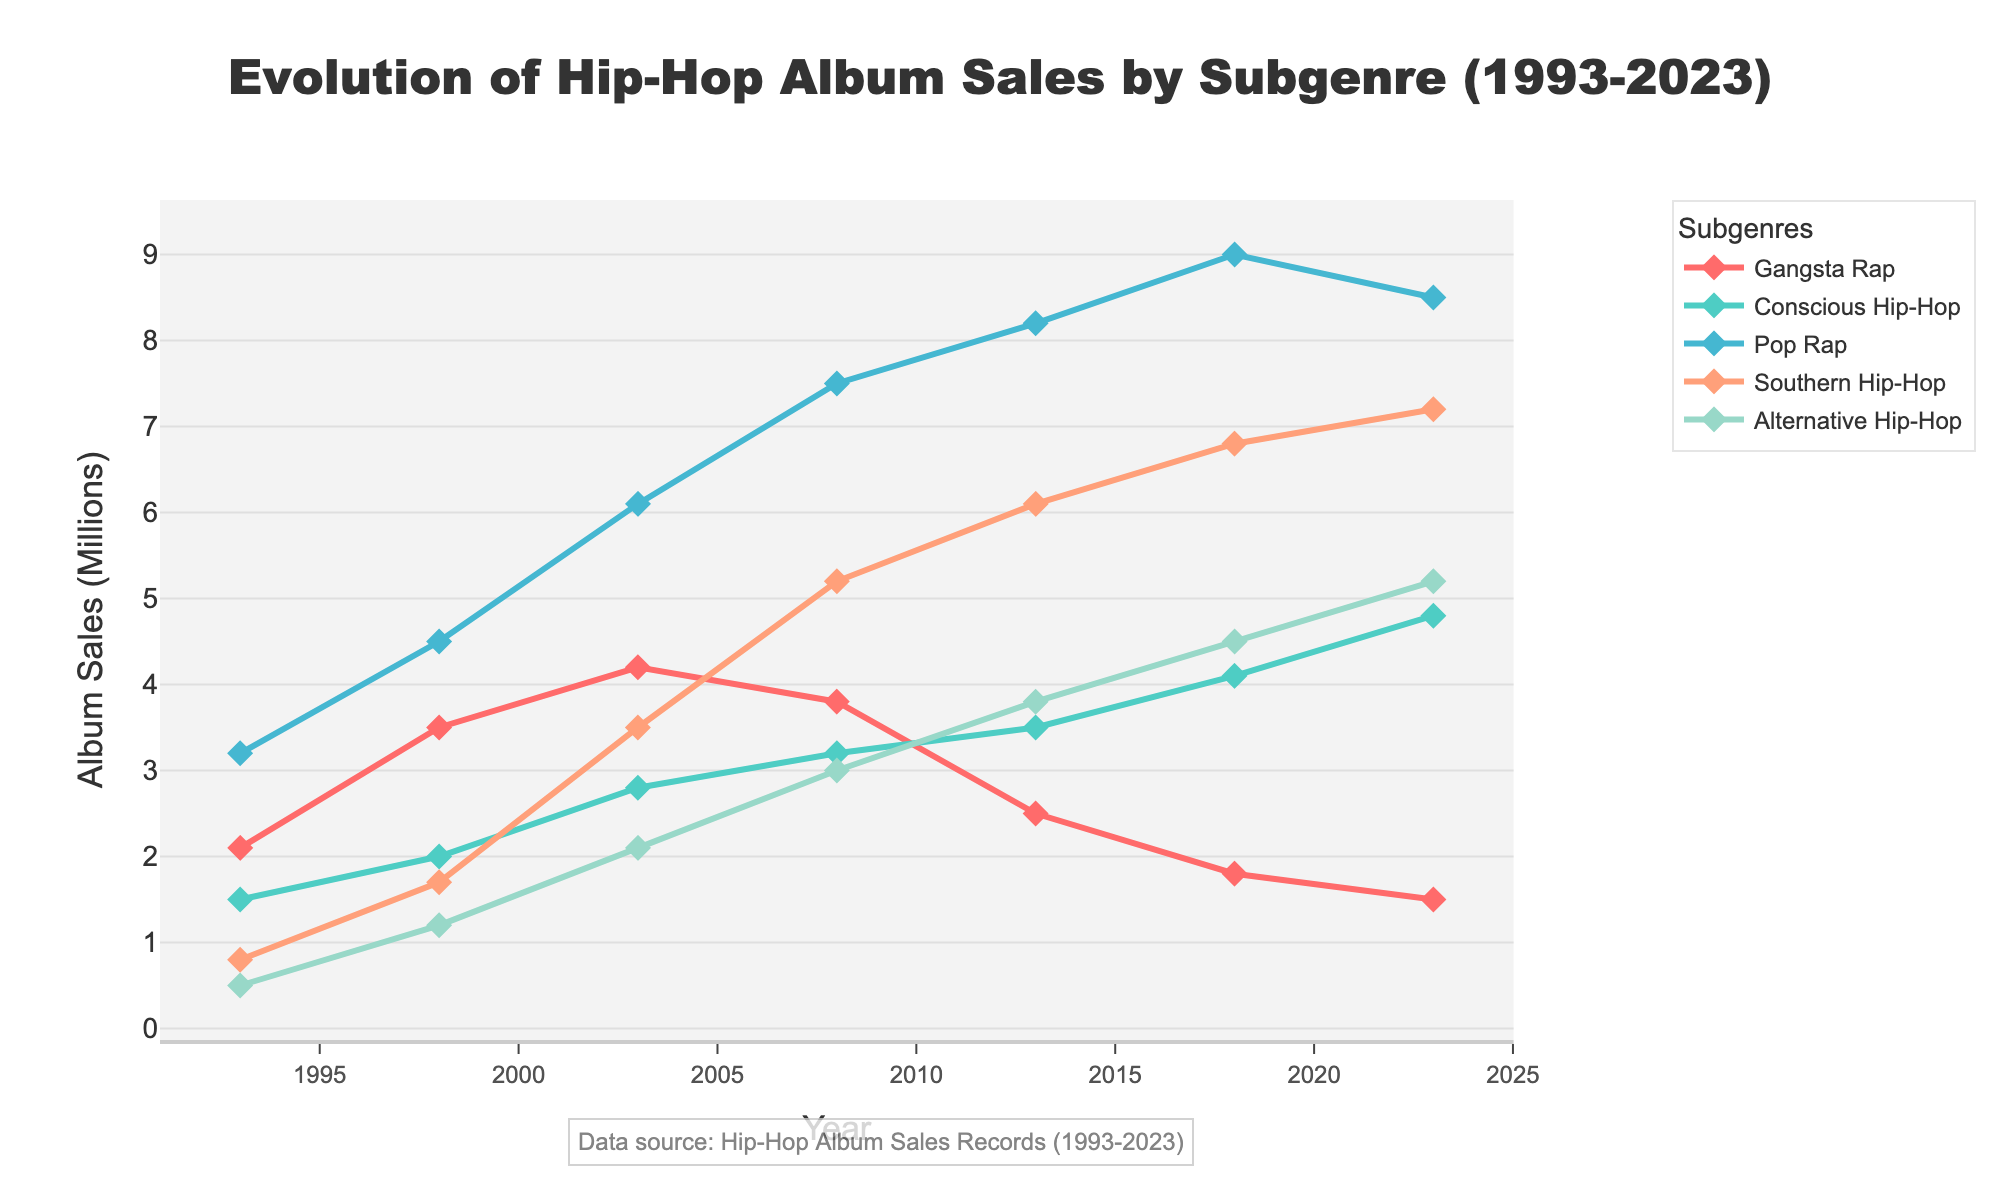What subgenre had the highest sales in 2003? To find the highest sales in 2003, look at the respective values for each subgenre in the year 2003. Pop Rap has the highest value (6.1 million).
Answer: Pop Rap Which subgenre showed the most consistent growth over the 30 years? To determine consistent growth, observe the trends of each subgenre from 1993 to 2023. Conscious Hip-Hop shows a steady increase from 1.5 million to 4.8 million.
Answer: Conscious Hip-Hop Between which two years did Southern Hip-Hop see the largest increase in sales? To identify the largest increase, calculate the year-to-year differences in sales for Southern Hip-Hop. The biggest increase is between 2003 (3.5 million) and 2008 (5.2 million), a difference of 1.7 million.
Answer: 2003 to 2008 How do the sales of Gangsta Rap in 2023 compare to 1993? Compare the values for Gangsta Rap in 1993 (2.1 million) and 2023 (1.5 million). Sales decreased by 0.6 million over 30 years.
Answer: Decreased Which subgenre had the highest peak in sales across all years? Look across the data points for each subgenre to find the highest single value. Pop Rap peaked at 9.0 million in 2018.
Answer: Pop Rap What is the total increase in sales for Alternative Hip-Hop from 1993 to 2023? Calculate the difference between 1993 (0.5 million) and 2023 (5.2 million) for Alternative Hip-Hop. The increase is 5.2 - 0.5 = 4.7 million.
Answer: 4.7 million Which subgenre had the steepest decline in sales at any point? To find the steepest decline, look for the largest decrease between consecutive years for each subgenre. Gangsta Rap had the steepest decline of 1.7 million from 2008 (3.8 million) to 2013 (2.5 million).
Answer: Gangsta Rap What is the average sales of Conscious Hip-Hop across all years? Sum the sales values for Conscious Hip-Hop across all years and divide by the number of years: (1.5 + 2.0 + 2.8 + 3.2 + 3.5 + 4.1 + 4.8) / 7 = 3.1286 million.
Answer: 3.13 million 